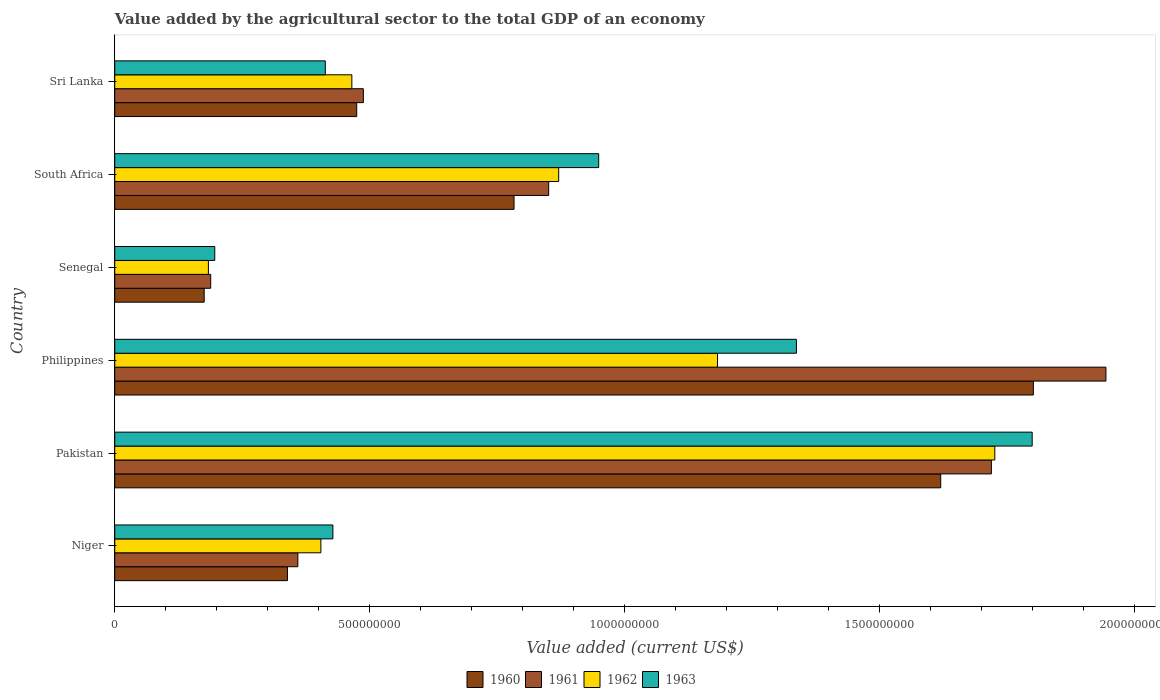How many different coloured bars are there?
Ensure brevity in your answer.  4. How many groups of bars are there?
Give a very brief answer. 6. How many bars are there on the 1st tick from the top?
Your answer should be compact. 4. How many bars are there on the 2nd tick from the bottom?
Offer a very short reply. 4. What is the label of the 6th group of bars from the top?
Your answer should be compact. Niger. In how many cases, is the number of bars for a given country not equal to the number of legend labels?
Keep it short and to the point. 0. What is the value added by the agricultural sector to the total GDP in 1963 in Senegal?
Make the answer very short. 1.96e+08. Across all countries, what is the maximum value added by the agricultural sector to the total GDP in 1963?
Make the answer very short. 1.80e+09. Across all countries, what is the minimum value added by the agricultural sector to the total GDP in 1962?
Keep it short and to the point. 1.84e+08. In which country was the value added by the agricultural sector to the total GDP in 1962 maximum?
Your answer should be compact. Pakistan. In which country was the value added by the agricultural sector to the total GDP in 1963 minimum?
Provide a succinct answer. Senegal. What is the total value added by the agricultural sector to the total GDP in 1963 in the graph?
Ensure brevity in your answer.  5.12e+09. What is the difference between the value added by the agricultural sector to the total GDP in 1963 in Niger and that in Pakistan?
Provide a short and direct response. -1.37e+09. What is the difference between the value added by the agricultural sector to the total GDP in 1961 in Senegal and the value added by the agricultural sector to the total GDP in 1963 in Philippines?
Offer a terse response. -1.15e+09. What is the average value added by the agricultural sector to the total GDP in 1962 per country?
Your response must be concise. 8.05e+08. What is the difference between the value added by the agricultural sector to the total GDP in 1961 and value added by the agricultural sector to the total GDP in 1962 in Philippines?
Make the answer very short. 7.61e+08. In how many countries, is the value added by the agricultural sector to the total GDP in 1963 greater than 400000000 US$?
Your answer should be very brief. 5. What is the ratio of the value added by the agricultural sector to the total GDP in 1960 in Philippines to that in Sri Lanka?
Your answer should be compact. 3.8. What is the difference between the highest and the second highest value added by the agricultural sector to the total GDP in 1961?
Your answer should be very brief. 2.25e+08. What is the difference between the highest and the lowest value added by the agricultural sector to the total GDP in 1962?
Your answer should be very brief. 1.54e+09. Is the sum of the value added by the agricultural sector to the total GDP in 1961 in Pakistan and South Africa greater than the maximum value added by the agricultural sector to the total GDP in 1963 across all countries?
Your answer should be compact. Yes. What does the 1st bar from the bottom in South Africa represents?
Keep it short and to the point. 1960. Is it the case that in every country, the sum of the value added by the agricultural sector to the total GDP in 1963 and value added by the agricultural sector to the total GDP in 1961 is greater than the value added by the agricultural sector to the total GDP in 1960?
Offer a very short reply. Yes. Are all the bars in the graph horizontal?
Provide a succinct answer. Yes. How many countries are there in the graph?
Give a very brief answer. 6. Does the graph contain grids?
Offer a terse response. No. What is the title of the graph?
Make the answer very short. Value added by the agricultural sector to the total GDP of an economy. Does "1974" appear as one of the legend labels in the graph?
Your answer should be very brief. No. What is the label or title of the X-axis?
Your answer should be very brief. Value added (current US$). What is the label or title of the Y-axis?
Offer a terse response. Country. What is the Value added (current US$) of 1960 in Niger?
Keep it short and to the point. 3.39e+08. What is the Value added (current US$) of 1961 in Niger?
Ensure brevity in your answer.  3.59e+08. What is the Value added (current US$) of 1962 in Niger?
Your answer should be very brief. 4.04e+08. What is the Value added (current US$) in 1963 in Niger?
Provide a short and direct response. 4.28e+08. What is the Value added (current US$) in 1960 in Pakistan?
Your response must be concise. 1.62e+09. What is the Value added (current US$) of 1961 in Pakistan?
Provide a succinct answer. 1.72e+09. What is the Value added (current US$) of 1962 in Pakistan?
Make the answer very short. 1.73e+09. What is the Value added (current US$) of 1963 in Pakistan?
Provide a succinct answer. 1.80e+09. What is the Value added (current US$) of 1960 in Philippines?
Your answer should be very brief. 1.80e+09. What is the Value added (current US$) in 1961 in Philippines?
Provide a short and direct response. 1.94e+09. What is the Value added (current US$) in 1962 in Philippines?
Give a very brief answer. 1.18e+09. What is the Value added (current US$) in 1963 in Philippines?
Your answer should be very brief. 1.34e+09. What is the Value added (current US$) of 1960 in Senegal?
Your response must be concise. 1.75e+08. What is the Value added (current US$) in 1961 in Senegal?
Ensure brevity in your answer.  1.88e+08. What is the Value added (current US$) in 1962 in Senegal?
Your response must be concise. 1.84e+08. What is the Value added (current US$) of 1963 in Senegal?
Your answer should be very brief. 1.96e+08. What is the Value added (current US$) of 1960 in South Africa?
Make the answer very short. 7.83e+08. What is the Value added (current US$) in 1961 in South Africa?
Your answer should be very brief. 8.51e+08. What is the Value added (current US$) of 1962 in South Africa?
Ensure brevity in your answer.  8.70e+08. What is the Value added (current US$) in 1963 in South Africa?
Your response must be concise. 9.49e+08. What is the Value added (current US$) in 1960 in Sri Lanka?
Your answer should be very brief. 4.74e+08. What is the Value added (current US$) of 1961 in Sri Lanka?
Provide a succinct answer. 4.87e+08. What is the Value added (current US$) in 1962 in Sri Lanka?
Keep it short and to the point. 4.65e+08. What is the Value added (current US$) of 1963 in Sri Lanka?
Provide a succinct answer. 4.13e+08. Across all countries, what is the maximum Value added (current US$) of 1960?
Provide a short and direct response. 1.80e+09. Across all countries, what is the maximum Value added (current US$) in 1961?
Your response must be concise. 1.94e+09. Across all countries, what is the maximum Value added (current US$) in 1962?
Provide a succinct answer. 1.73e+09. Across all countries, what is the maximum Value added (current US$) of 1963?
Your answer should be compact. 1.80e+09. Across all countries, what is the minimum Value added (current US$) of 1960?
Keep it short and to the point. 1.75e+08. Across all countries, what is the minimum Value added (current US$) of 1961?
Ensure brevity in your answer.  1.88e+08. Across all countries, what is the minimum Value added (current US$) of 1962?
Your answer should be compact. 1.84e+08. Across all countries, what is the minimum Value added (current US$) of 1963?
Make the answer very short. 1.96e+08. What is the total Value added (current US$) in 1960 in the graph?
Provide a succinct answer. 5.19e+09. What is the total Value added (current US$) in 1961 in the graph?
Your response must be concise. 5.55e+09. What is the total Value added (current US$) in 1962 in the graph?
Ensure brevity in your answer.  4.83e+09. What is the total Value added (current US$) in 1963 in the graph?
Your answer should be compact. 5.12e+09. What is the difference between the Value added (current US$) in 1960 in Niger and that in Pakistan?
Ensure brevity in your answer.  -1.28e+09. What is the difference between the Value added (current US$) of 1961 in Niger and that in Pakistan?
Offer a very short reply. -1.36e+09. What is the difference between the Value added (current US$) in 1962 in Niger and that in Pakistan?
Offer a very short reply. -1.32e+09. What is the difference between the Value added (current US$) in 1963 in Niger and that in Pakistan?
Offer a terse response. -1.37e+09. What is the difference between the Value added (current US$) in 1960 in Niger and that in Philippines?
Your answer should be compact. -1.46e+09. What is the difference between the Value added (current US$) of 1961 in Niger and that in Philippines?
Make the answer very short. -1.58e+09. What is the difference between the Value added (current US$) of 1962 in Niger and that in Philippines?
Your response must be concise. -7.78e+08. What is the difference between the Value added (current US$) in 1963 in Niger and that in Philippines?
Your answer should be compact. -9.09e+08. What is the difference between the Value added (current US$) of 1960 in Niger and that in Senegal?
Offer a very short reply. 1.63e+08. What is the difference between the Value added (current US$) in 1961 in Niger and that in Senegal?
Provide a short and direct response. 1.71e+08. What is the difference between the Value added (current US$) of 1962 in Niger and that in Senegal?
Make the answer very short. 2.21e+08. What is the difference between the Value added (current US$) in 1963 in Niger and that in Senegal?
Provide a succinct answer. 2.32e+08. What is the difference between the Value added (current US$) in 1960 in Niger and that in South Africa?
Offer a terse response. -4.44e+08. What is the difference between the Value added (current US$) in 1961 in Niger and that in South Africa?
Provide a succinct answer. -4.92e+08. What is the difference between the Value added (current US$) in 1962 in Niger and that in South Africa?
Offer a terse response. -4.66e+08. What is the difference between the Value added (current US$) in 1963 in Niger and that in South Africa?
Offer a very short reply. -5.21e+08. What is the difference between the Value added (current US$) in 1960 in Niger and that in Sri Lanka?
Ensure brevity in your answer.  -1.36e+08. What is the difference between the Value added (current US$) in 1961 in Niger and that in Sri Lanka?
Your answer should be very brief. -1.28e+08. What is the difference between the Value added (current US$) of 1962 in Niger and that in Sri Lanka?
Your response must be concise. -6.07e+07. What is the difference between the Value added (current US$) of 1963 in Niger and that in Sri Lanka?
Provide a short and direct response. 1.49e+07. What is the difference between the Value added (current US$) in 1960 in Pakistan and that in Philippines?
Keep it short and to the point. -1.82e+08. What is the difference between the Value added (current US$) in 1961 in Pakistan and that in Philippines?
Keep it short and to the point. -2.25e+08. What is the difference between the Value added (current US$) in 1962 in Pakistan and that in Philippines?
Keep it short and to the point. 5.44e+08. What is the difference between the Value added (current US$) of 1963 in Pakistan and that in Philippines?
Give a very brief answer. 4.62e+08. What is the difference between the Value added (current US$) of 1960 in Pakistan and that in Senegal?
Your answer should be compact. 1.44e+09. What is the difference between the Value added (current US$) of 1961 in Pakistan and that in Senegal?
Make the answer very short. 1.53e+09. What is the difference between the Value added (current US$) in 1962 in Pakistan and that in Senegal?
Give a very brief answer. 1.54e+09. What is the difference between the Value added (current US$) in 1963 in Pakistan and that in Senegal?
Keep it short and to the point. 1.60e+09. What is the difference between the Value added (current US$) of 1960 in Pakistan and that in South Africa?
Make the answer very short. 8.37e+08. What is the difference between the Value added (current US$) in 1961 in Pakistan and that in South Africa?
Your answer should be very brief. 8.68e+08. What is the difference between the Value added (current US$) of 1962 in Pakistan and that in South Africa?
Your answer should be very brief. 8.55e+08. What is the difference between the Value added (current US$) of 1963 in Pakistan and that in South Africa?
Provide a short and direct response. 8.50e+08. What is the difference between the Value added (current US$) in 1960 in Pakistan and that in Sri Lanka?
Ensure brevity in your answer.  1.14e+09. What is the difference between the Value added (current US$) of 1961 in Pakistan and that in Sri Lanka?
Give a very brief answer. 1.23e+09. What is the difference between the Value added (current US$) of 1962 in Pakistan and that in Sri Lanka?
Ensure brevity in your answer.  1.26e+09. What is the difference between the Value added (current US$) in 1963 in Pakistan and that in Sri Lanka?
Give a very brief answer. 1.39e+09. What is the difference between the Value added (current US$) in 1960 in Philippines and that in Senegal?
Your answer should be very brief. 1.63e+09. What is the difference between the Value added (current US$) in 1961 in Philippines and that in Senegal?
Give a very brief answer. 1.76e+09. What is the difference between the Value added (current US$) in 1962 in Philippines and that in Senegal?
Ensure brevity in your answer.  9.98e+08. What is the difference between the Value added (current US$) of 1963 in Philippines and that in Senegal?
Your response must be concise. 1.14e+09. What is the difference between the Value added (current US$) in 1960 in Philippines and that in South Africa?
Offer a terse response. 1.02e+09. What is the difference between the Value added (current US$) of 1961 in Philippines and that in South Africa?
Provide a short and direct response. 1.09e+09. What is the difference between the Value added (current US$) in 1962 in Philippines and that in South Africa?
Offer a terse response. 3.11e+08. What is the difference between the Value added (current US$) of 1963 in Philippines and that in South Africa?
Ensure brevity in your answer.  3.88e+08. What is the difference between the Value added (current US$) in 1960 in Philippines and that in Sri Lanka?
Provide a succinct answer. 1.33e+09. What is the difference between the Value added (current US$) in 1961 in Philippines and that in Sri Lanka?
Provide a short and direct response. 1.46e+09. What is the difference between the Value added (current US$) in 1962 in Philippines and that in Sri Lanka?
Offer a very short reply. 7.17e+08. What is the difference between the Value added (current US$) of 1963 in Philippines and that in Sri Lanka?
Offer a very short reply. 9.24e+08. What is the difference between the Value added (current US$) in 1960 in Senegal and that in South Africa?
Offer a terse response. -6.07e+08. What is the difference between the Value added (current US$) of 1961 in Senegal and that in South Africa?
Offer a very short reply. -6.63e+08. What is the difference between the Value added (current US$) of 1962 in Senegal and that in South Africa?
Give a very brief answer. -6.87e+08. What is the difference between the Value added (current US$) of 1963 in Senegal and that in South Africa?
Make the answer very short. -7.53e+08. What is the difference between the Value added (current US$) in 1960 in Senegal and that in Sri Lanka?
Offer a terse response. -2.99e+08. What is the difference between the Value added (current US$) of 1961 in Senegal and that in Sri Lanka?
Provide a succinct answer. -2.99e+08. What is the difference between the Value added (current US$) of 1962 in Senegal and that in Sri Lanka?
Offer a terse response. -2.81e+08. What is the difference between the Value added (current US$) of 1963 in Senegal and that in Sri Lanka?
Keep it short and to the point. -2.17e+08. What is the difference between the Value added (current US$) of 1960 in South Africa and that in Sri Lanka?
Make the answer very short. 3.08e+08. What is the difference between the Value added (current US$) of 1961 in South Africa and that in Sri Lanka?
Provide a short and direct response. 3.63e+08. What is the difference between the Value added (current US$) in 1962 in South Africa and that in Sri Lanka?
Provide a succinct answer. 4.06e+08. What is the difference between the Value added (current US$) of 1963 in South Africa and that in Sri Lanka?
Give a very brief answer. 5.36e+08. What is the difference between the Value added (current US$) in 1960 in Niger and the Value added (current US$) in 1961 in Pakistan?
Your answer should be very brief. -1.38e+09. What is the difference between the Value added (current US$) of 1960 in Niger and the Value added (current US$) of 1962 in Pakistan?
Keep it short and to the point. -1.39e+09. What is the difference between the Value added (current US$) of 1960 in Niger and the Value added (current US$) of 1963 in Pakistan?
Your answer should be compact. -1.46e+09. What is the difference between the Value added (current US$) of 1961 in Niger and the Value added (current US$) of 1962 in Pakistan?
Provide a succinct answer. -1.37e+09. What is the difference between the Value added (current US$) in 1961 in Niger and the Value added (current US$) in 1963 in Pakistan?
Provide a succinct answer. -1.44e+09. What is the difference between the Value added (current US$) in 1962 in Niger and the Value added (current US$) in 1963 in Pakistan?
Provide a succinct answer. -1.39e+09. What is the difference between the Value added (current US$) of 1960 in Niger and the Value added (current US$) of 1961 in Philippines?
Keep it short and to the point. -1.60e+09. What is the difference between the Value added (current US$) in 1960 in Niger and the Value added (current US$) in 1962 in Philippines?
Give a very brief answer. -8.43e+08. What is the difference between the Value added (current US$) in 1960 in Niger and the Value added (current US$) in 1963 in Philippines?
Offer a terse response. -9.98e+08. What is the difference between the Value added (current US$) in 1961 in Niger and the Value added (current US$) in 1962 in Philippines?
Offer a very short reply. -8.23e+08. What is the difference between the Value added (current US$) in 1961 in Niger and the Value added (current US$) in 1963 in Philippines?
Keep it short and to the point. -9.77e+08. What is the difference between the Value added (current US$) in 1962 in Niger and the Value added (current US$) in 1963 in Philippines?
Provide a succinct answer. -9.32e+08. What is the difference between the Value added (current US$) in 1960 in Niger and the Value added (current US$) in 1961 in Senegal?
Make the answer very short. 1.50e+08. What is the difference between the Value added (current US$) of 1960 in Niger and the Value added (current US$) of 1962 in Senegal?
Your answer should be compact. 1.55e+08. What is the difference between the Value added (current US$) of 1960 in Niger and the Value added (current US$) of 1963 in Senegal?
Offer a terse response. 1.43e+08. What is the difference between the Value added (current US$) of 1961 in Niger and the Value added (current US$) of 1962 in Senegal?
Give a very brief answer. 1.75e+08. What is the difference between the Value added (current US$) of 1961 in Niger and the Value added (current US$) of 1963 in Senegal?
Offer a very short reply. 1.63e+08. What is the difference between the Value added (current US$) in 1962 in Niger and the Value added (current US$) in 1963 in Senegal?
Make the answer very short. 2.08e+08. What is the difference between the Value added (current US$) in 1960 in Niger and the Value added (current US$) in 1961 in South Africa?
Offer a very short reply. -5.12e+08. What is the difference between the Value added (current US$) of 1960 in Niger and the Value added (current US$) of 1962 in South Africa?
Provide a succinct answer. -5.32e+08. What is the difference between the Value added (current US$) of 1960 in Niger and the Value added (current US$) of 1963 in South Africa?
Offer a very short reply. -6.10e+08. What is the difference between the Value added (current US$) in 1961 in Niger and the Value added (current US$) in 1962 in South Africa?
Provide a succinct answer. -5.11e+08. What is the difference between the Value added (current US$) in 1961 in Niger and the Value added (current US$) in 1963 in South Africa?
Your answer should be very brief. -5.90e+08. What is the difference between the Value added (current US$) in 1962 in Niger and the Value added (current US$) in 1963 in South Africa?
Provide a short and direct response. -5.45e+08. What is the difference between the Value added (current US$) in 1960 in Niger and the Value added (current US$) in 1961 in Sri Lanka?
Offer a terse response. -1.49e+08. What is the difference between the Value added (current US$) in 1960 in Niger and the Value added (current US$) in 1962 in Sri Lanka?
Ensure brevity in your answer.  -1.26e+08. What is the difference between the Value added (current US$) in 1960 in Niger and the Value added (current US$) in 1963 in Sri Lanka?
Your response must be concise. -7.42e+07. What is the difference between the Value added (current US$) of 1961 in Niger and the Value added (current US$) of 1962 in Sri Lanka?
Provide a succinct answer. -1.06e+08. What is the difference between the Value added (current US$) of 1961 in Niger and the Value added (current US$) of 1963 in Sri Lanka?
Your answer should be very brief. -5.38e+07. What is the difference between the Value added (current US$) in 1962 in Niger and the Value added (current US$) in 1963 in Sri Lanka?
Ensure brevity in your answer.  -8.67e+06. What is the difference between the Value added (current US$) of 1960 in Pakistan and the Value added (current US$) of 1961 in Philippines?
Make the answer very short. -3.24e+08. What is the difference between the Value added (current US$) of 1960 in Pakistan and the Value added (current US$) of 1962 in Philippines?
Your response must be concise. 4.38e+08. What is the difference between the Value added (current US$) of 1960 in Pakistan and the Value added (current US$) of 1963 in Philippines?
Provide a succinct answer. 2.83e+08. What is the difference between the Value added (current US$) of 1961 in Pakistan and the Value added (current US$) of 1962 in Philippines?
Offer a terse response. 5.37e+08. What is the difference between the Value added (current US$) of 1961 in Pakistan and the Value added (current US$) of 1963 in Philippines?
Your answer should be compact. 3.82e+08. What is the difference between the Value added (current US$) in 1962 in Pakistan and the Value added (current US$) in 1963 in Philippines?
Ensure brevity in your answer.  3.89e+08. What is the difference between the Value added (current US$) of 1960 in Pakistan and the Value added (current US$) of 1961 in Senegal?
Ensure brevity in your answer.  1.43e+09. What is the difference between the Value added (current US$) in 1960 in Pakistan and the Value added (current US$) in 1962 in Senegal?
Your response must be concise. 1.44e+09. What is the difference between the Value added (current US$) of 1960 in Pakistan and the Value added (current US$) of 1963 in Senegal?
Make the answer very short. 1.42e+09. What is the difference between the Value added (current US$) in 1961 in Pakistan and the Value added (current US$) in 1962 in Senegal?
Your answer should be very brief. 1.54e+09. What is the difference between the Value added (current US$) of 1961 in Pakistan and the Value added (current US$) of 1963 in Senegal?
Offer a very short reply. 1.52e+09. What is the difference between the Value added (current US$) of 1962 in Pakistan and the Value added (current US$) of 1963 in Senegal?
Offer a terse response. 1.53e+09. What is the difference between the Value added (current US$) in 1960 in Pakistan and the Value added (current US$) in 1961 in South Africa?
Keep it short and to the point. 7.69e+08. What is the difference between the Value added (current US$) in 1960 in Pakistan and the Value added (current US$) in 1962 in South Africa?
Offer a very short reply. 7.49e+08. What is the difference between the Value added (current US$) in 1960 in Pakistan and the Value added (current US$) in 1963 in South Africa?
Provide a short and direct response. 6.71e+08. What is the difference between the Value added (current US$) in 1961 in Pakistan and the Value added (current US$) in 1962 in South Africa?
Provide a short and direct response. 8.48e+08. What is the difference between the Value added (current US$) of 1961 in Pakistan and the Value added (current US$) of 1963 in South Africa?
Give a very brief answer. 7.70e+08. What is the difference between the Value added (current US$) of 1962 in Pakistan and the Value added (current US$) of 1963 in South Africa?
Provide a short and direct response. 7.77e+08. What is the difference between the Value added (current US$) of 1960 in Pakistan and the Value added (current US$) of 1961 in Sri Lanka?
Provide a short and direct response. 1.13e+09. What is the difference between the Value added (current US$) of 1960 in Pakistan and the Value added (current US$) of 1962 in Sri Lanka?
Your response must be concise. 1.15e+09. What is the difference between the Value added (current US$) in 1960 in Pakistan and the Value added (current US$) in 1963 in Sri Lanka?
Keep it short and to the point. 1.21e+09. What is the difference between the Value added (current US$) of 1961 in Pakistan and the Value added (current US$) of 1962 in Sri Lanka?
Make the answer very short. 1.25e+09. What is the difference between the Value added (current US$) in 1961 in Pakistan and the Value added (current US$) in 1963 in Sri Lanka?
Ensure brevity in your answer.  1.31e+09. What is the difference between the Value added (current US$) in 1962 in Pakistan and the Value added (current US$) in 1963 in Sri Lanka?
Provide a short and direct response. 1.31e+09. What is the difference between the Value added (current US$) of 1960 in Philippines and the Value added (current US$) of 1961 in Senegal?
Your answer should be compact. 1.61e+09. What is the difference between the Value added (current US$) of 1960 in Philippines and the Value added (current US$) of 1962 in Senegal?
Your answer should be compact. 1.62e+09. What is the difference between the Value added (current US$) of 1960 in Philippines and the Value added (current US$) of 1963 in Senegal?
Offer a terse response. 1.60e+09. What is the difference between the Value added (current US$) in 1961 in Philippines and the Value added (current US$) in 1962 in Senegal?
Provide a short and direct response. 1.76e+09. What is the difference between the Value added (current US$) in 1961 in Philippines and the Value added (current US$) in 1963 in Senegal?
Offer a very short reply. 1.75e+09. What is the difference between the Value added (current US$) in 1962 in Philippines and the Value added (current US$) in 1963 in Senegal?
Keep it short and to the point. 9.86e+08. What is the difference between the Value added (current US$) in 1960 in Philippines and the Value added (current US$) in 1961 in South Africa?
Your answer should be very brief. 9.50e+08. What is the difference between the Value added (current US$) in 1960 in Philippines and the Value added (current US$) in 1962 in South Africa?
Ensure brevity in your answer.  9.31e+08. What is the difference between the Value added (current US$) in 1960 in Philippines and the Value added (current US$) in 1963 in South Africa?
Your answer should be compact. 8.52e+08. What is the difference between the Value added (current US$) of 1961 in Philippines and the Value added (current US$) of 1962 in South Africa?
Your answer should be compact. 1.07e+09. What is the difference between the Value added (current US$) of 1961 in Philippines and the Value added (current US$) of 1963 in South Africa?
Offer a terse response. 9.94e+08. What is the difference between the Value added (current US$) of 1962 in Philippines and the Value added (current US$) of 1963 in South Africa?
Give a very brief answer. 2.33e+08. What is the difference between the Value added (current US$) in 1960 in Philippines and the Value added (current US$) in 1961 in Sri Lanka?
Your answer should be very brief. 1.31e+09. What is the difference between the Value added (current US$) of 1960 in Philippines and the Value added (current US$) of 1962 in Sri Lanka?
Ensure brevity in your answer.  1.34e+09. What is the difference between the Value added (current US$) in 1960 in Philippines and the Value added (current US$) in 1963 in Sri Lanka?
Your response must be concise. 1.39e+09. What is the difference between the Value added (current US$) of 1961 in Philippines and the Value added (current US$) of 1962 in Sri Lanka?
Keep it short and to the point. 1.48e+09. What is the difference between the Value added (current US$) of 1961 in Philippines and the Value added (current US$) of 1963 in Sri Lanka?
Provide a succinct answer. 1.53e+09. What is the difference between the Value added (current US$) of 1962 in Philippines and the Value added (current US$) of 1963 in Sri Lanka?
Provide a short and direct response. 7.69e+08. What is the difference between the Value added (current US$) in 1960 in Senegal and the Value added (current US$) in 1961 in South Africa?
Give a very brief answer. -6.75e+08. What is the difference between the Value added (current US$) of 1960 in Senegal and the Value added (current US$) of 1962 in South Africa?
Ensure brevity in your answer.  -6.95e+08. What is the difference between the Value added (current US$) of 1960 in Senegal and the Value added (current US$) of 1963 in South Africa?
Provide a succinct answer. -7.73e+08. What is the difference between the Value added (current US$) in 1961 in Senegal and the Value added (current US$) in 1962 in South Africa?
Provide a short and direct response. -6.82e+08. What is the difference between the Value added (current US$) in 1961 in Senegal and the Value added (current US$) in 1963 in South Africa?
Make the answer very short. -7.61e+08. What is the difference between the Value added (current US$) of 1962 in Senegal and the Value added (current US$) of 1963 in South Africa?
Give a very brief answer. -7.65e+08. What is the difference between the Value added (current US$) in 1960 in Senegal and the Value added (current US$) in 1961 in Sri Lanka?
Make the answer very short. -3.12e+08. What is the difference between the Value added (current US$) of 1960 in Senegal and the Value added (current US$) of 1962 in Sri Lanka?
Provide a succinct answer. -2.89e+08. What is the difference between the Value added (current US$) in 1960 in Senegal and the Value added (current US$) in 1963 in Sri Lanka?
Keep it short and to the point. -2.37e+08. What is the difference between the Value added (current US$) of 1961 in Senegal and the Value added (current US$) of 1962 in Sri Lanka?
Offer a very short reply. -2.77e+08. What is the difference between the Value added (current US$) in 1961 in Senegal and the Value added (current US$) in 1963 in Sri Lanka?
Provide a short and direct response. -2.25e+08. What is the difference between the Value added (current US$) of 1962 in Senegal and the Value added (current US$) of 1963 in Sri Lanka?
Offer a very short reply. -2.29e+08. What is the difference between the Value added (current US$) of 1960 in South Africa and the Value added (current US$) of 1961 in Sri Lanka?
Offer a terse response. 2.95e+08. What is the difference between the Value added (current US$) in 1960 in South Africa and the Value added (current US$) in 1962 in Sri Lanka?
Give a very brief answer. 3.18e+08. What is the difference between the Value added (current US$) in 1960 in South Africa and the Value added (current US$) in 1963 in Sri Lanka?
Keep it short and to the point. 3.70e+08. What is the difference between the Value added (current US$) in 1961 in South Africa and the Value added (current US$) in 1962 in Sri Lanka?
Offer a terse response. 3.86e+08. What is the difference between the Value added (current US$) of 1961 in South Africa and the Value added (current US$) of 1963 in Sri Lanka?
Your answer should be very brief. 4.38e+08. What is the difference between the Value added (current US$) in 1962 in South Africa and the Value added (current US$) in 1963 in Sri Lanka?
Your answer should be very brief. 4.58e+08. What is the average Value added (current US$) of 1960 per country?
Your answer should be compact. 8.65e+08. What is the average Value added (current US$) of 1961 per country?
Your response must be concise. 9.24e+08. What is the average Value added (current US$) in 1962 per country?
Your answer should be compact. 8.05e+08. What is the average Value added (current US$) of 1963 per country?
Make the answer very short. 8.53e+08. What is the difference between the Value added (current US$) in 1960 and Value added (current US$) in 1961 in Niger?
Provide a succinct answer. -2.03e+07. What is the difference between the Value added (current US$) of 1960 and Value added (current US$) of 1962 in Niger?
Provide a short and direct response. -6.55e+07. What is the difference between the Value added (current US$) of 1960 and Value added (current US$) of 1963 in Niger?
Provide a succinct answer. -8.91e+07. What is the difference between the Value added (current US$) in 1961 and Value added (current US$) in 1962 in Niger?
Provide a succinct answer. -4.52e+07. What is the difference between the Value added (current US$) in 1961 and Value added (current US$) in 1963 in Niger?
Provide a short and direct response. -6.88e+07. What is the difference between the Value added (current US$) in 1962 and Value added (current US$) in 1963 in Niger?
Give a very brief answer. -2.36e+07. What is the difference between the Value added (current US$) in 1960 and Value added (current US$) in 1961 in Pakistan?
Ensure brevity in your answer.  -9.93e+07. What is the difference between the Value added (current US$) in 1960 and Value added (current US$) in 1962 in Pakistan?
Give a very brief answer. -1.06e+08. What is the difference between the Value added (current US$) in 1960 and Value added (current US$) in 1963 in Pakistan?
Offer a terse response. -1.79e+08. What is the difference between the Value added (current US$) of 1961 and Value added (current US$) of 1962 in Pakistan?
Offer a very short reply. -6.72e+06. What is the difference between the Value added (current US$) in 1961 and Value added (current US$) in 1963 in Pakistan?
Provide a short and direct response. -8.00e+07. What is the difference between the Value added (current US$) of 1962 and Value added (current US$) of 1963 in Pakistan?
Your answer should be compact. -7.33e+07. What is the difference between the Value added (current US$) in 1960 and Value added (current US$) in 1961 in Philippines?
Your answer should be very brief. -1.42e+08. What is the difference between the Value added (current US$) of 1960 and Value added (current US$) of 1962 in Philippines?
Make the answer very short. 6.19e+08. What is the difference between the Value added (current US$) in 1960 and Value added (current US$) in 1963 in Philippines?
Your answer should be very brief. 4.64e+08. What is the difference between the Value added (current US$) of 1961 and Value added (current US$) of 1962 in Philippines?
Offer a very short reply. 7.61e+08. What is the difference between the Value added (current US$) of 1961 and Value added (current US$) of 1963 in Philippines?
Your response must be concise. 6.07e+08. What is the difference between the Value added (current US$) of 1962 and Value added (current US$) of 1963 in Philippines?
Your answer should be compact. -1.55e+08. What is the difference between the Value added (current US$) of 1960 and Value added (current US$) of 1961 in Senegal?
Provide a short and direct response. -1.28e+07. What is the difference between the Value added (current US$) in 1960 and Value added (current US$) in 1962 in Senegal?
Offer a terse response. -8.24e+06. What is the difference between the Value added (current US$) in 1960 and Value added (current US$) in 1963 in Senegal?
Provide a short and direct response. -2.07e+07. What is the difference between the Value added (current US$) of 1961 and Value added (current US$) of 1962 in Senegal?
Offer a terse response. 4.54e+06. What is the difference between the Value added (current US$) of 1961 and Value added (current US$) of 1963 in Senegal?
Provide a succinct answer. -7.96e+06. What is the difference between the Value added (current US$) of 1962 and Value added (current US$) of 1963 in Senegal?
Your answer should be very brief. -1.25e+07. What is the difference between the Value added (current US$) of 1960 and Value added (current US$) of 1961 in South Africa?
Your response must be concise. -6.80e+07. What is the difference between the Value added (current US$) of 1960 and Value added (current US$) of 1962 in South Africa?
Your answer should be compact. -8.76e+07. What is the difference between the Value added (current US$) of 1960 and Value added (current US$) of 1963 in South Africa?
Offer a very short reply. -1.66e+08. What is the difference between the Value added (current US$) in 1961 and Value added (current US$) in 1962 in South Africa?
Ensure brevity in your answer.  -1.96e+07. What is the difference between the Value added (current US$) of 1961 and Value added (current US$) of 1963 in South Africa?
Your answer should be very brief. -9.80e+07. What is the difference between the Value added (current US$) in 1962 and Value added (current US$) in 1963 in South Africa?
Keep it short and to the point. -7.84e+07. What is the difference between the Value added (current US$) in 1960 and Value added (current US$) in 1961 in Sri Lanka?
Keep it short and to the point. -1.30e+07. What is the difference between the Value added (current US$) in 1960 and Value added (current US$) in 1962 in Sri Lanka?
Offer a very short reply. 9.55e+06. What is the difference between the Value added (current US$) in 1960 and Value added (current US$) in 1963 in Sri Lanka?
Your answer should be very brief. 6.16e+07. What is the difference between the Value added (current US$) in 1961 and Value added (current US$) in 1962 in Sri Lanka?
Give a very brief answer. 2.26e+07. What is the difference between the Value added (current US$) in 1961 and Value added (current US$) in 1963 in Sri Lanka?
Your response must be concise. 7.46e+07. What is the difference between the Value added (current US$) of 1962 and Value added (current US$) of 1963 in Sri Lanka?
Provide a short and direct response. 5.20e+07. What is the ratio of the Value added (current US$) of 1960 in Niger to that in Pakistan?
Offer a terse response. 0.21. What is the ratio of the Value added (current US$) in 1961 in Niger to that in Pakistan?
Make the answer very short. 0.21. What is the ratio of the Value added (current US$) of 1962 in Niger to that in Pakistan?
Your answer should be very brief. 0.23. What is the ratio of the Value added (current US$) of 1963 in Niger to that in Pakistan?
Make the answer very short. 0.24. What is the ratio of the Value added (current US$) of 1960 in Niger to that in Philippines?
Your answer should be very brief. 0.19. What is the ratio of the Value added (current US$) of 1961 in Niger to that in Philippines?
Provide a succinct answer. 0.18. What is the ratio of the Value added (current US$) in 1962 in Niger to that in Philippines?
Your answer should be compact. 0.34. What is the ratio of the Value added (current US$) of 1963 in Niger to that in Philippines?
Keep it short and to the point. 0.32. What is the ratio of the Value added (current US$) of 1960 in Niger to that in Senegal?
Provide a short and direct response. 1.93. What is the ratio of the Value added (current US$) in 1961 in Niger to that in Senegal?
Provide a short and direct response. 1.91. What is the ratio of the Value added (current US$) in 1962 in Niger to that in Senegal?
Make the answer very short. 2.2. What is the ratio of the Value added (current US$) in 1963 in Niger to that in Senegal?
Provide a succinct answer. 2.18. What is the ratio of the Value added (current US$) in 1960 in Niger to that in South Africa?
Make the answer very short. 0.43. What is the ratio of the Value added (current US$) of 1961 in Niger to that in South Africa?
Give a very brief answer. 0.42. What is the ratio of the Value added (current US$) in 1962 in Niger to that in South Africa?
Your answer should be very brief. 0.46. What is the ratio of the Value added (current US$) of 1963 in Niger to that in South Africa?
Provide a succinct answer. 0.45. What is the ratio of the Value added (current US$) in 1960 in Niger to that in Sri Lanka?
Offer a very short reply. 0.71. What is the ratio of the Value added (current US$) of 1961 in Niger to that in Sri Lanka?
Offer a terse response. 0.74. What is the ratio of the Value added (current US$) of 1962 in Niger to that in Sri Lanka?
Offer a terse response. 0.87. What is the ratio of the Value added (current US$) in 1963 in Niger to that in Sri Lanka?
Keep it short and to the point. 1.04. What is the ratio of the Value added (current US$) in 1960 in Pakistan to that in Philippines?
Your answer should be very brief. 0.9. What is the ratio of the Value added (current US$) in 1961 in Pakistan to that in Philippines?
Your answer should be very brief. 0.88. What is the ratio of the Value added (current US$) in 1962 in Pakistan to that in Philippines?
Give a very brief answer. 1.46. What is the ratio of the Value added (current US$) in 1963 in Pakistan to that in Philippines?
Provide a succinct answer. 1.35. What is the ratio of the Value added (current US$) of 1960 in Pakistan to that in Senegal?
Provide a short and direct response. 9.24. What is the ratio of the Value added (current US$) in 1961 in Pakistan to that in Senegal?
Provide a succinct answer. 9.14. What is the ratio of the Value added (current US$) in 1962 in Pakistan to that in Senegal?
Give a very brief answer. 9.4. What is the ratio of the Value added (current US$) of 1963 in Pakistan to that in Senegal?
Your answer should be very brief. 9.17. What is the ratio of the Value added (current US$) in 1960 in Pakistan to that in South Africa?
Provide a succinct answer. 2.07. What is the ratio of the Value added (current US$) of 1961 in Pakistan to that in South Africa?
Give a very brief answer. 2.02. What is the ratio of the Value added (current US$) in 1962 in Pakistan to that in South Africa?
Keep it short and to the point. 1.98. What is the ratio of the Value added (current US$) of 1963 in Pakistan to that in South Africa?
Give a very brief answer. 1.9. What is the ratio of the Value added (current US$) in 1960 in Pakistan to that in Sri Lanka?
Your answer should be very brief. 3.41. What is the ratio of the Value added (current US$) in 1961 in Pakistan to that in Sri Lanka?
Your response must be concise. 3.53. What is the ratio of the Value added (current US$) in 1962 in Pakistan to that in Sri Lanka?
Your response must be concise. 3.71. What is the ratio of the Value added (current US$) of 1963 in Pakistan to that in Sri Lanka?
Your answer should be very brief. 4.36. What is the ratio of the Value added (current US$) in 1960 in Philippines to that in Senegal?
Provide a succinct answer. 10.27. What is the ratio of the Value added (current US$) in 1961 in Philippines to that in Senegal?
Offer a very short reply. 10.33. What is the ratio of the Value added (current US$) in 1962 in Philippines to that in Senegal?
Make the answer very short. 6.44. What is the ratio of the Value added (current US$) in 1963 in Philippines to that in Senegal?
Your response must be concise. 6.82. What is the ratio of the Value added (current US$) in 1960 in Philippines to that in South Africa?
Provide a succinct answer. 2.3. What is the ratio of the Value added (current US$) in 1961 in Philippines to that in South Africa?
Offer a very short reply. 2.28. What is the ratio of the Value added (current US$) of 1962 in Philippines to that in South Africa?
Make the answer very short. 1.36. What is the ratio of the Value added (current US$) in 1963 in Philippines to that in South Africa?
Offer a terse response. 1.41. What is the ratio of the Value added (current US$) in 1960 in Philippines to that in Sri Lanka?
Your response must be concise. 3.8. What is the ratio of the Value added (current US$) of 1961 in Philippines to that in Sri Lanka?
Provide a succinct answer. 3.99. What is the ratio of the Value added (current US$) of 1962 in Philippines to that in Sri Lanka?
Ensure brevity in your answer.  2.54. What is the ratio of the Value added (current US$) in 1963 in Philippines to that in Sri Lanka?
Give a very brief answer. 3.24. What is the ratio of the Value added (current US$) of 1960 in Senegal to that in South Africa?
Make the answer very short. 0.22. What is the ratio of the Value added (current US$) in 1961 in Senegal to that in South Africa?
Your answer should be compact. 0.22. What is the ratio of the Value added (current US$) in 1962 in Senegal to that in South Africa?
Make the answer very short. 0.21. What is the ratio of the Value added (current US$) in 1963 in Senegal to that in South Africa?
Your answer should be very brief. 0.21. What is the ratio of the Value added (current US$) in 1960 in Senegal to that in Sri Lanka?
Make the answer very short. 0.37. What is the ratio of the Value added (current US$) in 1961 in Senegal to that in Sri Lanka?
Make the answer very short. 0.39. What is the ratio of the Value added (current US$) of 1962 in Senegal to that in Sri Lanka?
Your answer should be compact. 0.39. What is the ratio of the Value added (current US$) in 1963 in Senegal to that in Sri Lanka?
Make the answer very short. 0.47. What is the ratio of the Value added (current US$) in 1960 in South Africa to that in Sri Lanka?
Provide a succinct answer. 1.65. What is the ratio of the Value added (current US$) in 1961 in South Africa to that in Sri Lanka?
Offer a very short reply. 1.75. What is the ratio of the Value added (current US$) in 1962 in South Africa to that in Sri Lanka?
Provide a short and direct response. 1.87. What is the ratio of the Value added (current US$) of 1963 in South Africa to that in Sri Lanka?
Give a very brief answer. 2.3. What is the difference between the highest and the second highest Value added (current US$) of 1960?
Offer a terse response. 1.82e+08. What is the difference between the highest and the second highest Value added (current US$) in 1961?
Your response must be concise. 2.25e+08. What is the difference between the highest and the second highest Value added (current US$) of 1962?
Provide a short and direct response. 5.44e+08. What is the difference between the highest and the second highest Value added (current US$) of 1963?
Keep it short and to the point. 4.62e+08. What is the difference between the highest and the lowest Value added (current US$) in 1960?
Offer a terse response. 1.63e+09. What is the difference between the highest and the lowest Value added (current US$) of 1961?
Offer a very short reply. 1.76e+09. What is the difference between the highest and the lowest Value added (current US$) in 1962?
Your answer should be compact. 1.54e+09. What is the difference between the highest and the lowest Value added (current US$) in 1963?
Your response must be concise. 1.60e+09. 